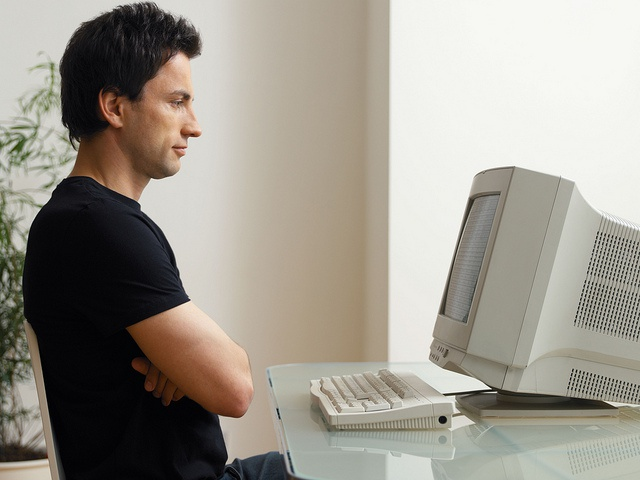Describe the objects in this image and their specific colors. I can see people in lightgray, black, maroon, gray, and tan tones, tv in lightgray, darkgray, and gray tones, potted plant in lightgray, darkgray, and gray tones, and keyboard in lightgray, darkgray, and gray tones in this image. 